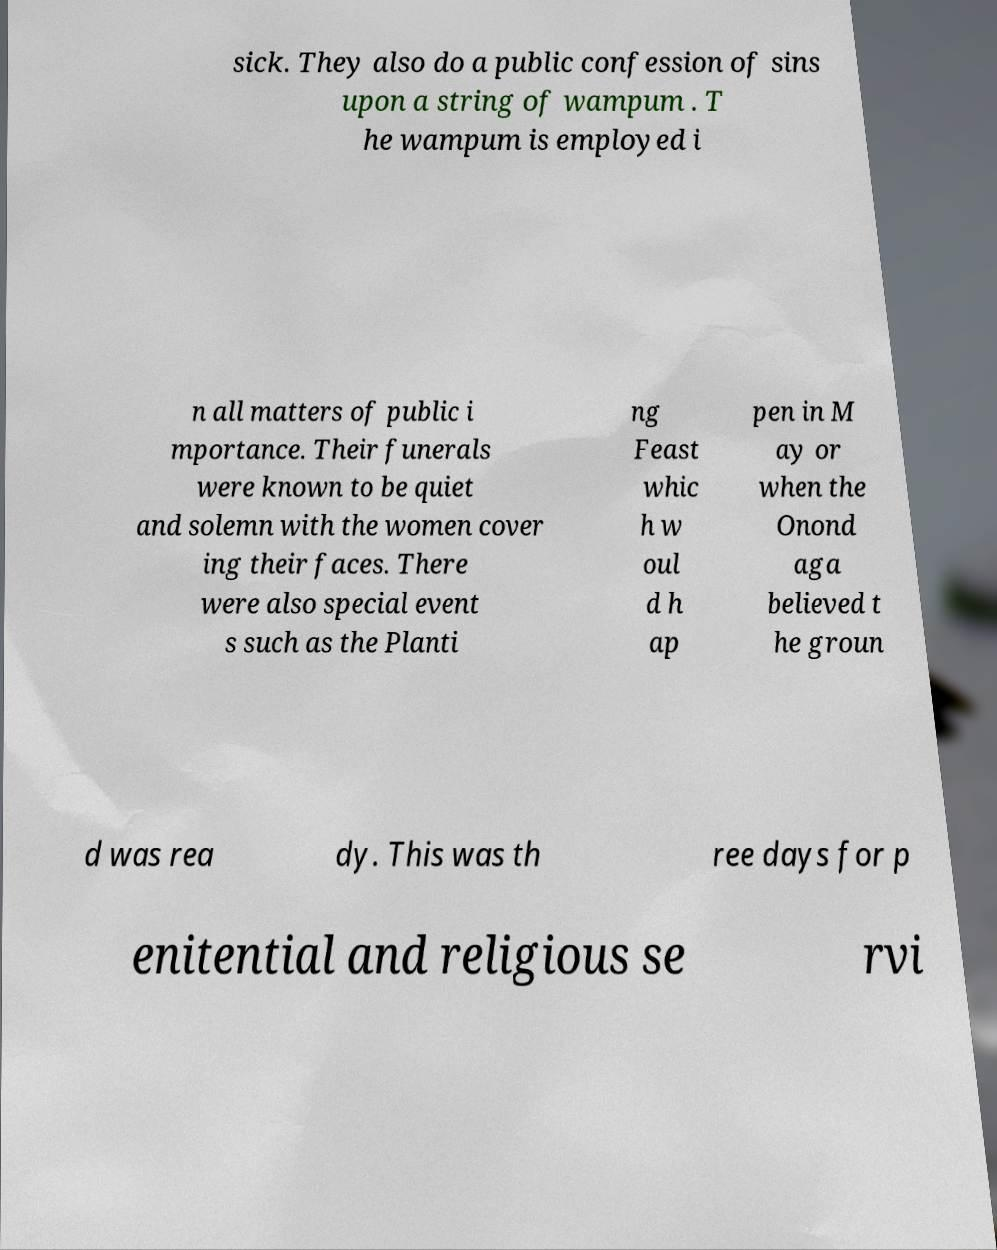Can you accurately transcribe the text from the provided image for me? sick. They also do a public confession of sins upon a string of wampum . T he wampum is employed i n all matters of public i mportance. Their funerals were known to be quiet and solemn with the women cover ing their faces. There were also special event s such as the Planti ng Feast whic h w oul d h ap pen in M ay or when the Onond aga believed t he groun d was rea dy. This was th ree days for p enitential and religious se rvi 